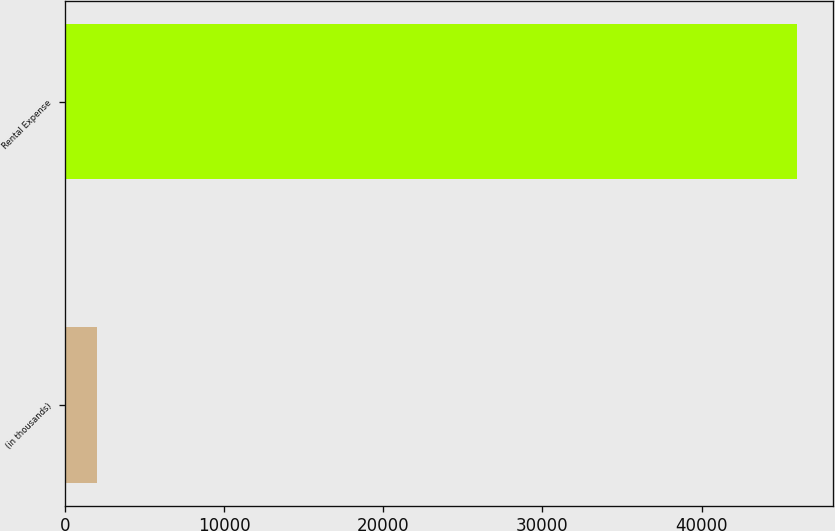Convert chart. <chart><loc_0><loc_0><loc_500><loc_500><bar_chart><fcel>(in thousands)<fcel>Rental Expense<nl><fcel>2011<fcel>45958<nl></chart> 